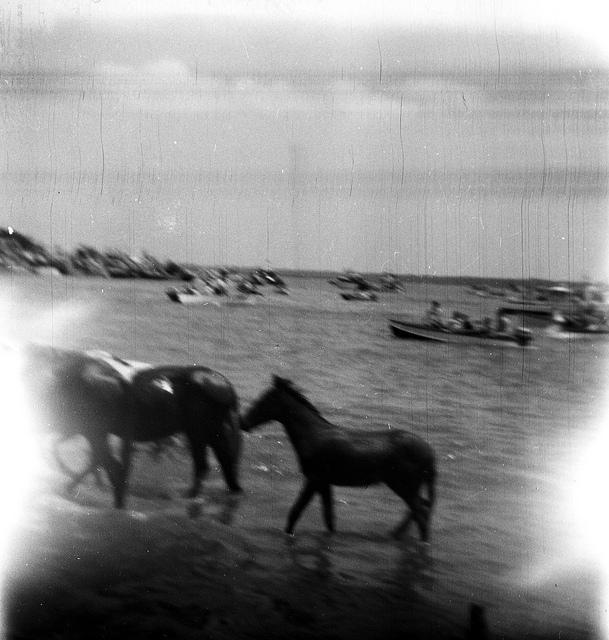How many horses are in the photo?
Give a very brief answer. 3. How many horses are there?
Give a very brief answer. 2. 